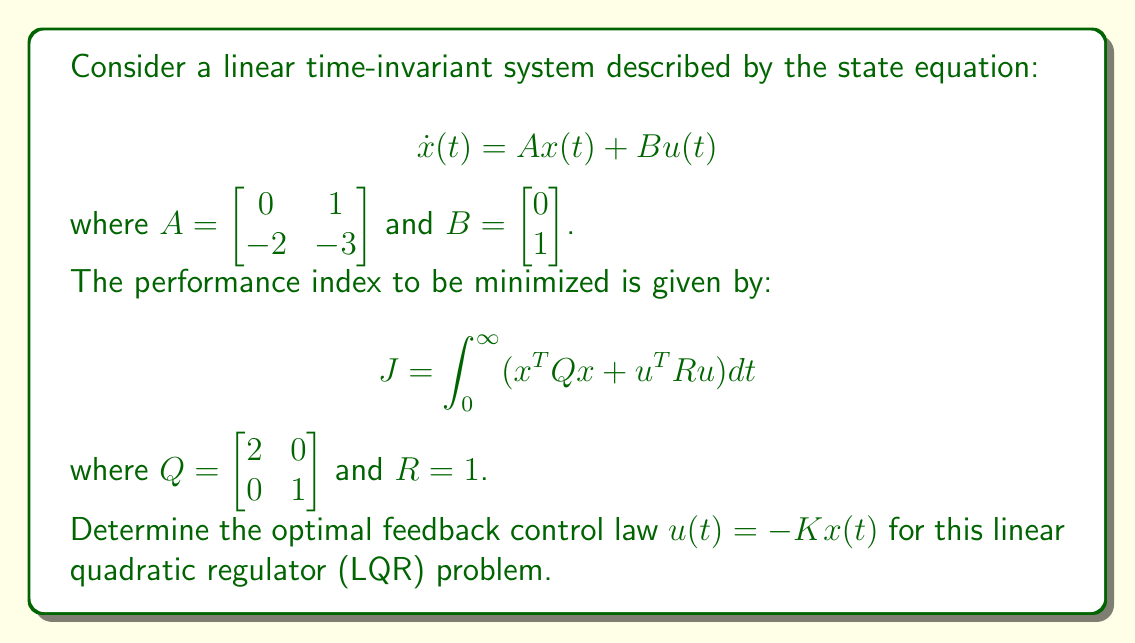Give your solution to this math problem. To solve this LQR problem, we need to follow these steps:

1) First, we need to solve the algebraic Riccati equation (ARE):

   $$A^TP + PA - PBR^{-1}B^TP + Q = 0$$

2) Let $P = \begin{bmatrix} p_{11} & p_{12} \\ p_{12} & p_{22} \end{bmatrix}$. Substituting the given matrices into the ARE:

   $$\begin{bmatrix} 0 & -2 \\ 1 & -3 \end{bmatrix} \begin{bmatrix} p_{11} & p_{12} \\ p_{12} & p_{22} \end{bmatrix} + \begin{bmatrix} p_{11} & p_{12} \\ p_{12} & p_{22} \end{bmatrix} \begin{bmatrix} 0 & 1 \\ -2 & -3 \end{bmatrix} - \begin{bmatrix} p_{11} & p_{12} \\ p_{12} & p_{22} \end{bmatrix} \begin{bmatrix} 0 \\ 1 \end{bmatrix} [1] \begin{bmatrix} 0 & 1 \end{bmatrix} \begin{bmatrix} p_{11} & p_{12} \\ p_{12} & p_{22} \end{bmatrix} + \begin{bmatrix} 2 & 0 \\ 0 & 1 \end{bmatrix} = 0$$

3) This results in three equations:

   $$-2p_{12} - 2p_{12} - p_{12}^2 + 2 = 0$$
   $$-2p_{22} + p_{11} - 3p_{12} - p_{12}p_{22} = 0$$
   $$2p_{12} - 6p_{22} - p_{22}^2 + 1 = 0$$

4) Solving these equations (which can be done numerically), we get:

   $$P = \begin{bmatrix} 2.4142 & 0.7321 \\ 0.7321 & 1.2679 \end{bmatrix}$$

5) Now, we can calculate the optimal feedback gain matrix K:

   $$K = R^{-1}B^TP = [1]^{-1} \begin{bmatrix} 0 & 1 \end{bmatrix} \begin{bmatrix} 2.4142 & 0.7321 \\ 0.7321 & 1.2679 \end{bmatrix} = \begin{bmatrix} 0.7321 & 1.2679 \end{bmatrix}$$

Therefore, the optimal control law is:

$$u(t) = -Kx(t) = -0.7321x_1(t) - 1.2679x_2(t)$$

where $x_1(t)$ and $x_2(t)$ are the components of the state vector $x(t)$.
Answer: The optimal feedback control law is:

$$u(t) = -Kx(t) = -0.7321x_1(t) - 1.2679x_2(t)$$

where $K = \begin{bmatrix} 0.7321 & 1.2679 \end{bmatrix}$. 